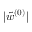<formula> <loc_0><loc_0><loc_500><loc_500>| \tilde { w } ^ { ( 0 ) } |</formula> 